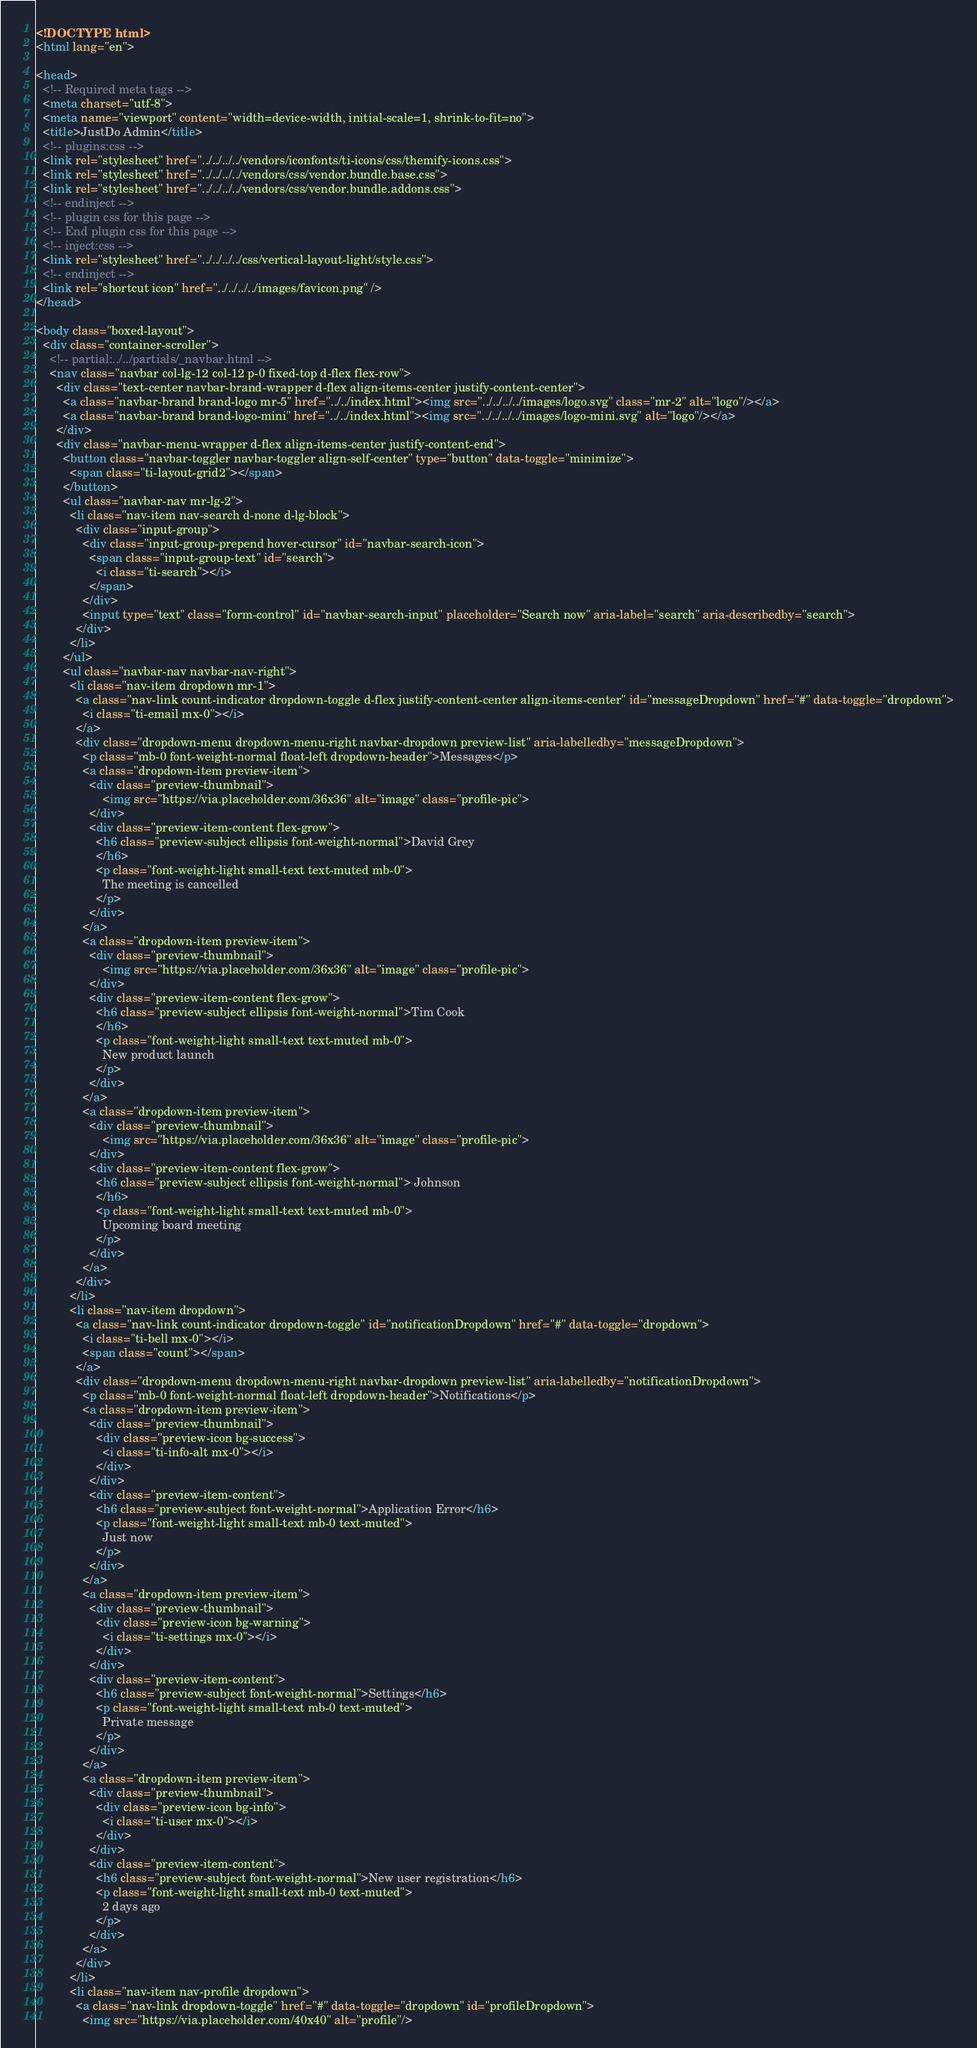Convert code to text. <code><loc_0><loc_0><loc_500><loc_500><_HTML_><!DOCTYPE html>
<html lang="en">

<head>
  <!-- Required meta tags -->
  <meta charset="utf-8">
  <meta name="viewport" content="width=device-width, initial-scale=1, shrink-to-fit=no">
  <title>JustDo Admin</title>
  <!-- plugins:css -->
  <link rel="stylesheet" href="../../../../vendors/iconfonts/ti-icons/css/themify-icons.css">
  <link rel="stylesheet" href="../../../../vendors/css/vendor.bundle.base.css">
  <link rel="stylesheet" href="../../../../vendors/css/vendor.bundle.addons.css">
  <!-- endinject -->
  <!-- plugin css for this page -->
  <!-- End plugin css for this page -->
  <!-- inject:css -->
  <link rel="stylesheet" href="../../../../css/vertical-layout-light/style.css">
  <!-- endinject -->
  <link rel="shortcut icon" href="../../../../images/favicon.png" />
</head>

<body class="boxed-layout">
  <div class="container-scroller">
    <!-- partial:../../partials/_navbar.html -->
    <nav class="navbar col-lg-12 col-12 p-0 fixed-top d-flex flex-row">
      <div class="text-center navbar-brand-wrapper d-flex align-items-center justify-content-center">
        <a class="navbar-brand brand-logo mr-5" href="../../index.html"><img src="../../../../images/logo.svg" class="mr-2" alt="logo"/></a>
        <a class="navbar-brand brand-logo-mini" href="../../index.html"><img src="../../../../images/logo-mini.svg" alt="logo"/></a>
      </div>
      <div class="navbar-menu-wrapper d-flex align-items-center justify-content-end">
        <button class="navbar-toggler navbar-toggler align-self-center" type="button" data-toggle="minimize">
          <span class="ti-layout-grid2"></span>
        </button>
        <ul class="navbar-nav mr-lg-2">
          <li class="nav-item nav-search d-none d-lg-block">
            <div class="input-group">
              <div class="input-group-prepend hover-cursor" id="navbar-search-icon">
                <span class="input-group-text" id="search">
                  <i class="ti-search"></i>
                </span>
              </div>
              <input type="text" class="form-control" id="navbar-search-input" placeholder="Search now" aria-label="search" aria-describedby="search">
            </div>
          </li>
        </ul>
        <ul class="navbar-nav navbar-nav-right">
          <li class="nav-item dropdown mr-1">
            <a class="nav-link count-indicator dropdown-toggle d-flex justify-content-center align-items-center" id="messageDropdown" href="#" data-toggle="dropdown">
              <i class="ti-email mx-0"></i>
            </a>
            <div class="dropdown-menu dropdown-menu-right navbar-dropdown preview-list" aria-labelledby="messageDropdown">
              <p class="mb-0 font-weight-normal float-left dropdown-header">Messages</p>
              <a class="dropdown-item preview-item">
                <div class="preview-thumbnail">
                    <img src="https://via.placeholder.com/36x36" alt="image" class="profile-pic">
                </div>
                <div class="preview-item-content flex-grow">
                  <h6 class="preview-subject ellipsis font-weight-normal">David Grey
                  </h6>
                  <p class="font-weight-light small-text text-muted mb-0">
                    The meeting is cancelled
                  </p>
                </div>
              </a>
              <a class="dropdown-item preview-item">
                <div class="preview-thumbnail">
                    <img src="https://via.placeholder.com/36x36" alt="image" class="profile-pic">
                </div>
                <div class="preview-item-content flex-grow">
                  <h6 class="preview-subject ellipsis font-weight-normal">Tim Cook
                  </h6>
                  <p class="font-weight-light small-text text-muted mb-0">
                    New product launch
                  </p>
                </div>
              </a>
              <a class="dropdown-item preview-item">
                <div class="preview-thumbnail">
                    <img src="https://via.placeholder.com/36x36" alt="image" class="profile-pic">
                </div>
                <div class="preview-item-content flex-grow">
                  <h6 class="preview-subject ellipsis font-weight-normal"> Johnson
                  </h6>
                  <p class="font-weight-light small-text text-muted mb-0">
                    Upcoming board meeting
                  </p>
                </div>
              </a>
            </div>
          </li>
          <li class="nav-item dropdown">
            <a class="nav-link count-indicator dropdown-toggle" id="notificationDropdown" href="#" data-toggle="dropdown">
              <i class="ti-bell mx-0"></i>
              <span class="count"></span>
            </a>
            <div class="dropdown-menu dropdown-menu-right navbar-dropdown preview-list" aria-labelledby="notificationDropdown">
              <p class="mb-0 font-weight-normal float-left dropdown-header">Notifications</p>
              <a class="dropdown-item preview-item">
                <div class="preview-thumbnail">
                  <div class="preview-icon bg-success">
                    <i class="ti-info-alt mx-0"></i>
                  </div>
                </div>
                <div class="preview-item-content">
                  <h6 class="preview-subject font-weight-normal">Application Error</h6>
                  <p class="font-weight-light small-text mb-0 text-muted">
                    Just now
                  </p>
                </div>
              </a>
              <a class="dropdown-item preview-item">
                <div class="preview-thumbnail">
                  <div class="preview-icon bg-warning">
                    <i class="ti-settings mx-0"></i>
                  </div>
                </div>
                <div class="preview-item-content">
                  <h6 class="preview-subject font-weight-normal">Settings</h6>
                  <p class="font-weight-light small-text mb-0 text-muted">
                    Private message
                  </p>
                </div>
              </a>
              <a class="dropdown-item preview-item">
                <div class="preview-thumbnail">
                  <div class="preview-icon bg-info">
                    <i class="ti-user mx-0"></i>
                  </div>
                </div>
                <div class="preview-item-content">
                  <h6 class="preview-subject font-weight-normal">New user registration</h6>
                  <p class="font-weight-light small-text mb-0 text-muted">
                    2 days ago
                  </p>
                </div>
              </a>
            </div>
          </li>
          <li class="nav-item nav-profile dropdown">
            <a class="nav-link dropdown-toggle" href="#" data-toggle="dropdown" id="profileDropdown">
              <img src="https://via.placeholder.com/40x40" alt="profile"/></code> 